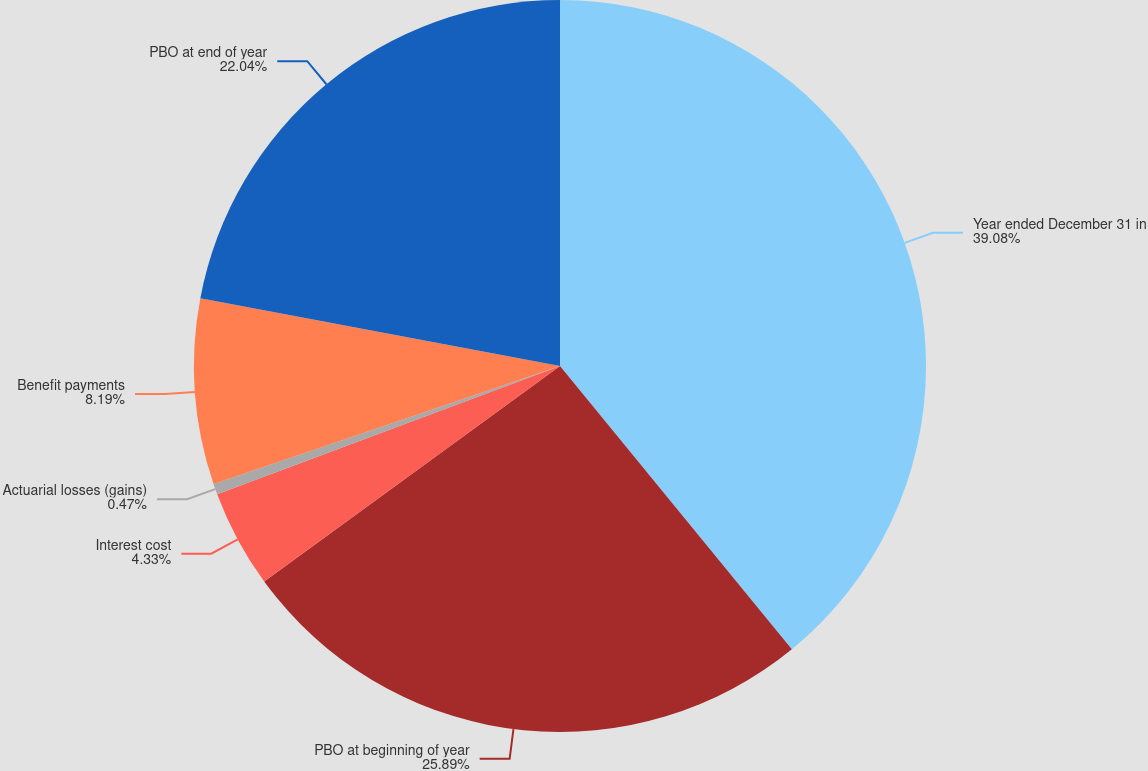<chart> <loc_0><loc_0><loc_500><loc_500><pie_chart><fcel>Year ended December 31 in<fcel>PBO at beginning of year<fcel>Interest cost<fcel>Actuarial losses (gains)<fcel>Benefit payments<fcel>PBO at end of year<nl><fcel>39.09%<fcel>25.9%<fcel>4.33%<fcel>0.47%<fcel>8.19%<fcel>22.04%<nl></chart> 